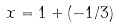<formula> <loc_0><loc_0><loc_500><loc_500>x = 1 + ( - 1 / 3 )</formula> 